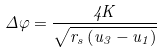Convert formula to latex. <formula><loc_0><loc_0><loc_500><loc_500>\Delta \varphi = { \frac { 4 K } { \sqrt { r _ { s } \left ( u _ { 3 } - u _ { 1 } \right ) } } }</formula> 